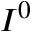Convert formula to latex. <formula><loc_0><loc_0><loc_500><loc_500>I ^ { 0 }</formula> 